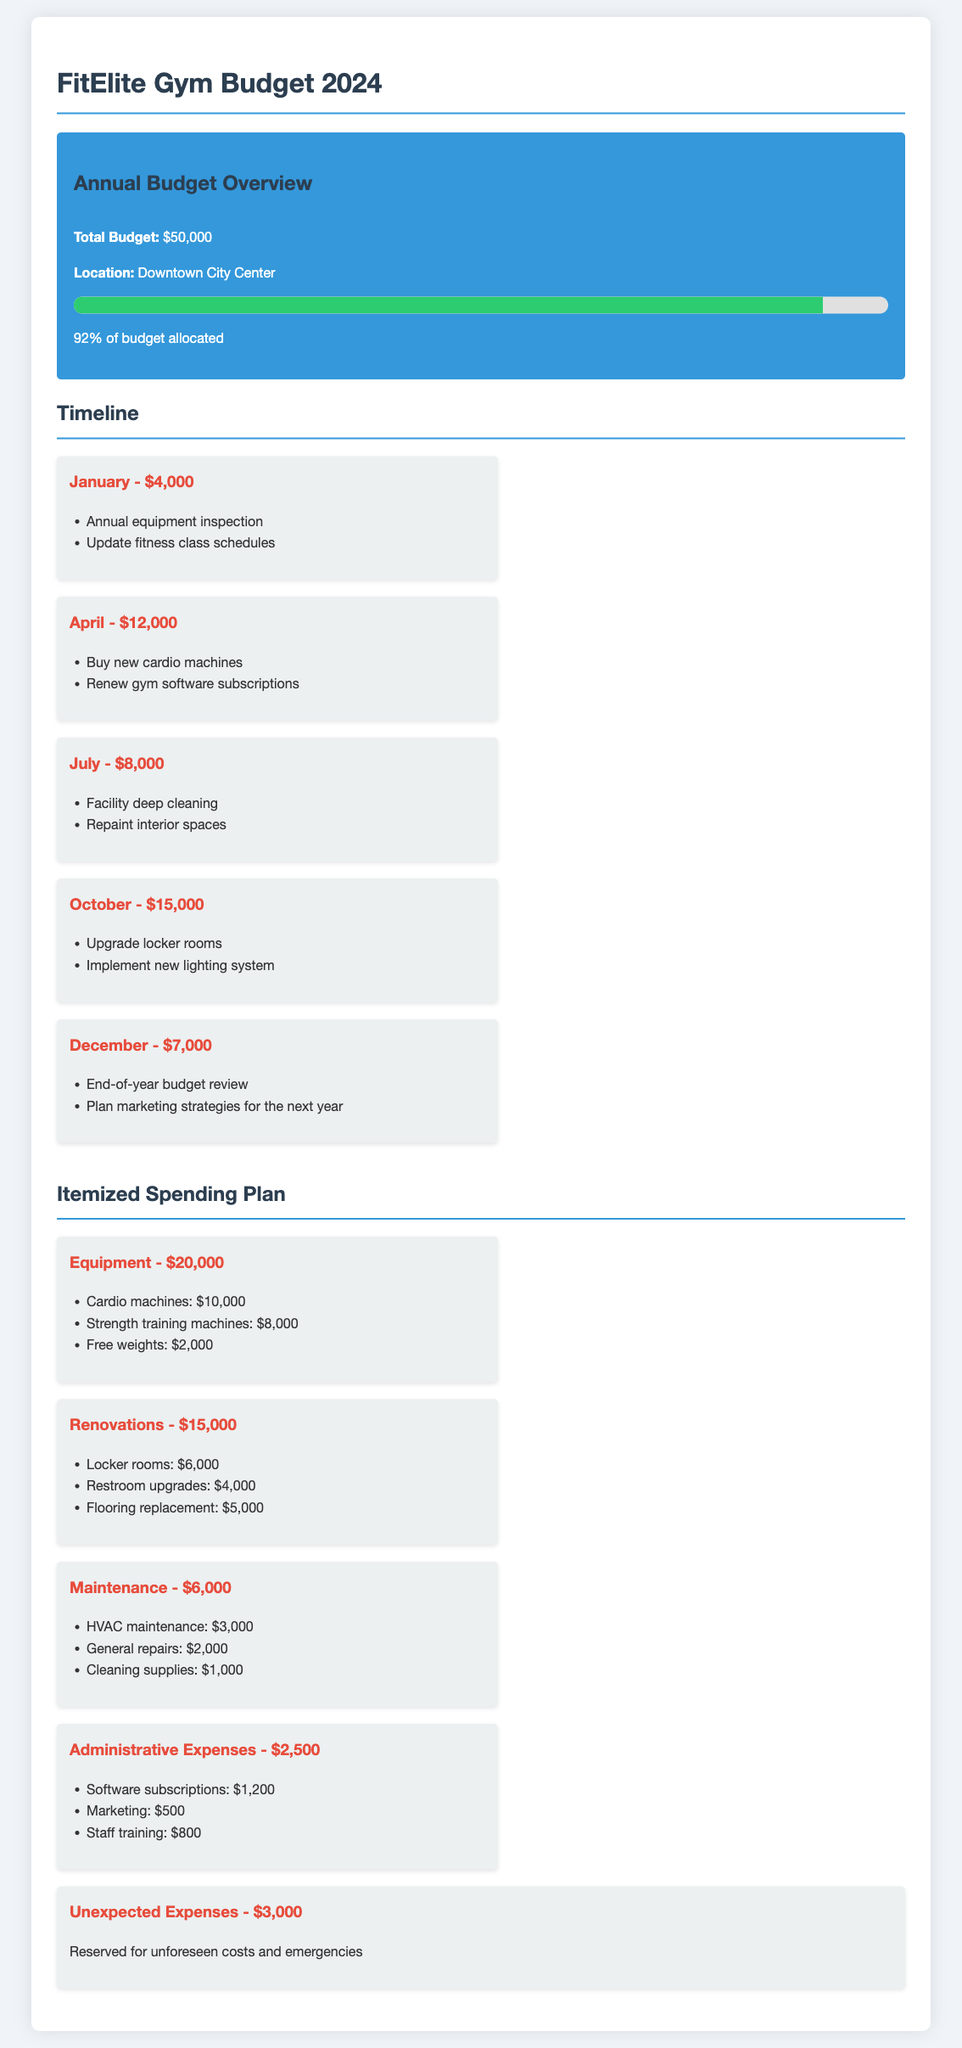What is the total budget for FitElite Gym in 2024? The total budget is clearly stated in the budget overview section of the document.
Answer: $50,000 What is the allocated amount for renovations? The itemized spending plan section specifies the budget allocation for renovations.
Answer: $15,000 When is the facility deep cleaning scheduled? The timeline lists the activities along with their scheduled months and amounts.
Answer: July What percentage of the budget is allocated as of now? The progress bar indicates the current allocation percentage in the budget overview section.
Answer: 92% How much is reserved for unexpected expenses? The document mentions the amount set aside for unforeseen costs in the itemized spending plan.
Answer: $3,000 What is the budget for new cardio machines? The equipment section specifies the budget allocated for cardio machines.
Answer: $10,000 Which month has the highest budget allocation? The timeline outlines the monthly allocations, and October shows the highest amount.
Answer: October How much is allocated for administrative expenses? The itemized spending plan section provides the specific budget for administrative expenses.
Answer: $2,500 What is the total spending on equipment? The itemized spending plan sums up all equipment costs listed.
Answer: $20,000 